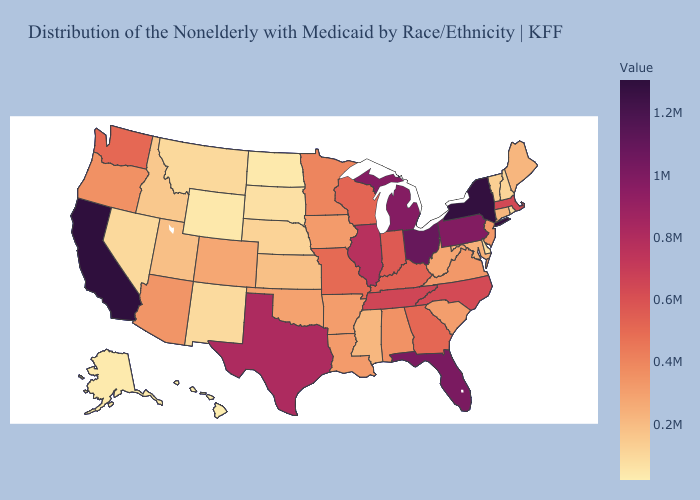Does Indiana have the highest value in the USA?
Be succinct. No. Does California have the highest value in the USA?
Be succinct. Yes. Among the states that border Arizona , which have the highest value?
Answer briefly. California. Which states have the lowest value in the Northeast?
Short answer required. Rhode Island. Which states have the highest value in the USA?
Short answer required. California. Does the map have missing data?
Give a very brief answer. No. Which states have the highest value in the USA?
Concise answer only. California. 